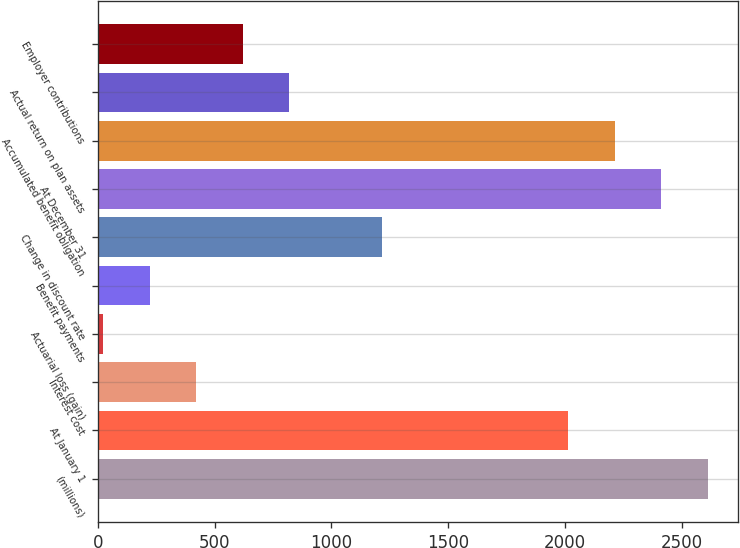Convert chart. <chart><loc_0><loc_0><loc_500><loc_500><bar_chart><fcel>(millions)<fcel>At January 1<fcel>Interest cost<fcel>Actuarial loss (gain)<fcel>Benefit payments<fcel>Change in discount rate<fcel>At December 31<fcel>Accumulated benefit obligation<fcel>Actual return on plan assets<fcel>Employer contributions<nl><fcel>2608.7<fcel>2012<fcel>420.8<fcel>23<fcel>221.9<fcel>1216.4<fcel>2409.8<fcel>2210.9<fcel>818.6<fcel>619.7<nl></chart> 